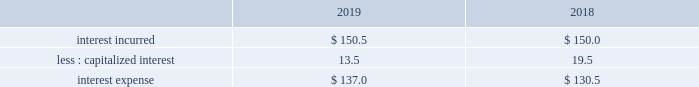Interest expense .
Interest incurred increased $ .5 as interest expense associated with financing the lu'an joint venture was mostly offset by favorable impacts from currency , a lower average interest rate on the debt portfolio , and a lower average debt balance .
Capitalized interest decreased 31% ( 31 % ) , or $ 6.0 , due to a decrease in the carrying value of projects under construction , primarily driven by the lu'an project in asia .
Other non-operating income ( expense ) , net other non-operating income ( expense ) , net of $ 66.7 increased $ 61.6 , primarily due to lower pension settlement losses , higher non-service pension income , and higher interest income on cash and cash items .
The prior year included pension settlement losses of $ 43.7 ( $ 33.2 after-tax , or $ .15 per share ) primarily in connection with the transfer of certain pension assets and payment obligations to an insurer for our u.s .
Salaried and hourly plans .
In fiscal year 2019 , we recognized a pension settlement loss of $ 5.0 ( $ 3.8 after-tax , or $ .02 per share ) associated with the u.s .
Supplementary pension plan during the second quarter .
Net income and net income margin net income of $ 1809.4 increased 18% ( 18 % ) , or $ 276.5 , primarily due to impacts from the u.s .
Tax cuts and jobs act , positive pricing , and favorable volumes .
Net income margin of 20.3% ( 20.3 % ) increased 310 bp .
Adjusted ebitda and adjusted ebitda margin adjusted ebitda of $ 3468.0 increased 11% ( 11 % ) , or $ 352.5 , primarily due to positive pricing and higher volumes , partially offset by unfavorable currency .
Adjusted ebitda margin of 38.9% ( 38.9 % ) increased 400 bp , primarily due to higher volumes , positive pricing , and the india contract modification .
The india contract modification contributed 80 bp .
Effective tax rate the effective tax rate equals the income tax provision divided by income from continuing operations before taxes .
The effective tax rate was 21.0% ( 21.0 % ) and 26.0% ( 26.0 % ) in fiscal years 2019 and 2018 , respectively .
The current year rate was lower primarily due to impacts related to the enactment of the u.s .
Tax cuts and jobs act ( the 201ctax act" ) in 2018 , which significantly changed existing u.s .
Tax laws , including a reduction in the federal corporate income tax rate from 35% ( 35 % ) to 21% ( 21 % ) , a deemed repatriation tax on unremitted foreign earnings , as well as other changes .
As a result of the tax act , our income tax provision reflects discrete net income tax costs of $ 43.8 and $ 180.6 in fiscal years 2019 and 2018 , respectively .
The current year included a cost of $ 56.2 ( $ .26 per share ) for the reversal of a benefit recorded in 2018 related to the u.s .
Taxation of deemed foreign dividends .
We recorded this reversal based on regulations issued in 2019 .
The 2019 reversal was partially offset by a favorable adjustment of $ 12.4 ( $ .06 per share ) that was recorded as we completed our estimates of the impacts of the tax act .
This adjustment is primarily related to foreign tax items , including the deemed repatriation tax for foreign tax redeterminations .
In addition , the current year rate included a net gain on the exchange of two equity affiliates of $ 29.1 , which was not a taxable transaction .
The higher 2018 expense resulting from the tax act was partially offset by a $ 35.7 tax benefit from the restructuring of foreign subsidiaries , a $ 9.1 benefit from a foreign audit settlement agreement , and higher excess tax benefits on share-based compensation .
The adjusted effective tax rate was 19.4% ( 19.4 % ) and 18.6% ( 18.6 % ) in fiscal years 2019 and 2018 , respectively .
The lower prior year rate was primarily due to the $ 9.1 benefit from a foreign audit settlement agreement and higher excess tax benefits on share-based compensation. .
What is the variation of the effective tax rate considering the years 2018-2019? 
Rationale: it is the difference between those effective tax rates during these years .
Computations: (26.0% - 21.0%)
Answer: 0.05. 